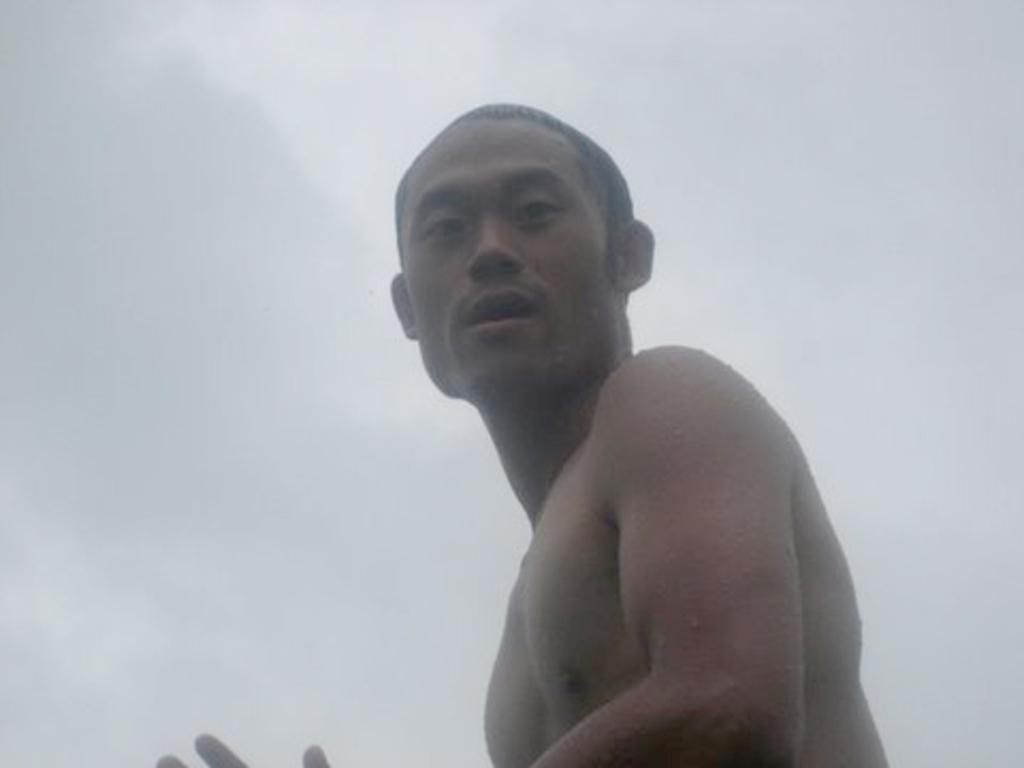Where was the image taken? The image was taken outdoors. What can be seen in the background of the image? There is a sky with clouds visible in the background. Can you describe the main subject of the image? There is a man in the middle of the image. What type of house is depicted in the science verse in the image? There is no house, science, or verse present in the image; it features a man outdoors with a sky and clouds in the background. 